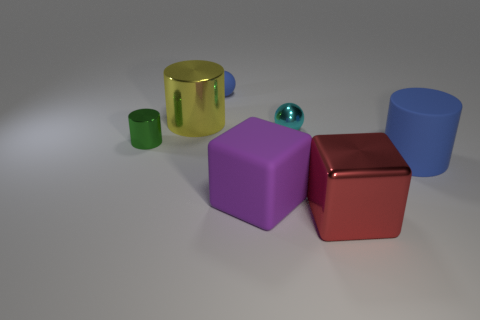Are any big purple things visible?
Provide a succinct answer. Yes. The object that is on the left side of the cyan metallic object and right of the blue sphere has what shape?
Ensure brevity in your answer.  Cube. There is a yellow shiny cylinder that is on the left side of the blue rubber cylinder; what size is it?
Your answer should be very brief. Large. There is a large cylinder right of the large red metal cube; is it the same color as the tiny rubber ball?
Offer a terse response. Yes. How many other big rubber objects have the same shape as the red object?
Make the answer very short. 1. What number of things are either objects behind the big rubber cylinder or things behind the large red thing?
Ensure brevity in your answer.  6. What number of gray objects are cubes or big cylinders?
Provide a succinct answer. 0. There is a big object that is both to the right of the tiny blue ball and left of the metallic block; what material is it?
Keep it short and to the point. Rubber. Are the tiny cyan thing and the blue cylinder made of the same material?
Your answer should be very brief. No. What number of other cylinders have the same size as the blue matte cylinder?
Provide a short and direct response. 1. 